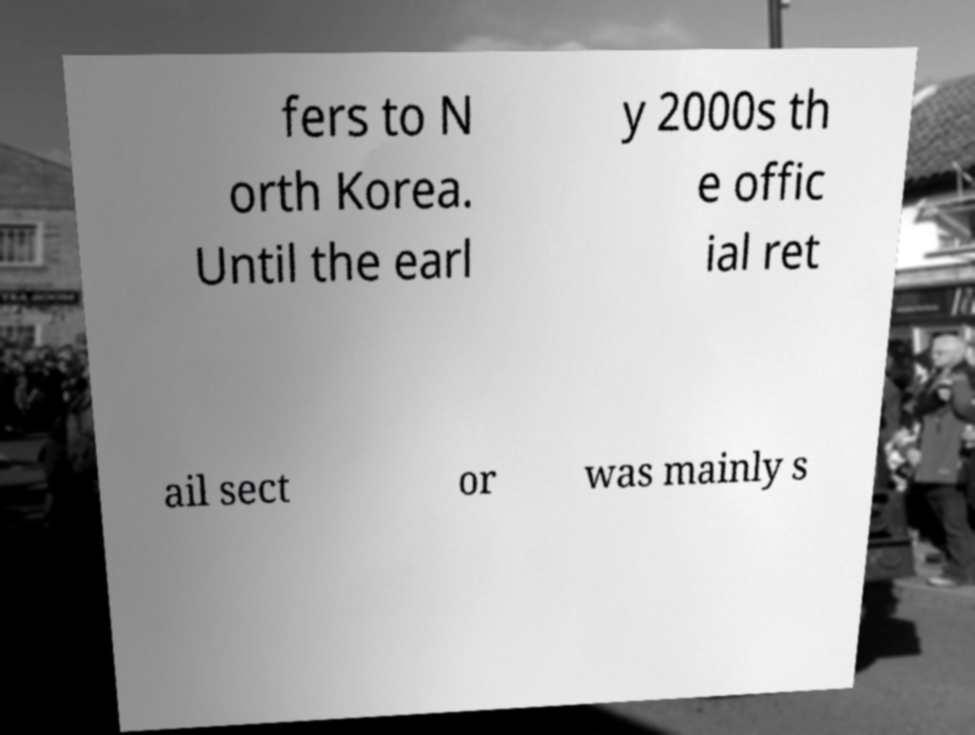Please identify and transcribe the text found in this image. fers to N orth Korea. Until the earl y 2000s th e offic ial ret ail sect or was mainly s 